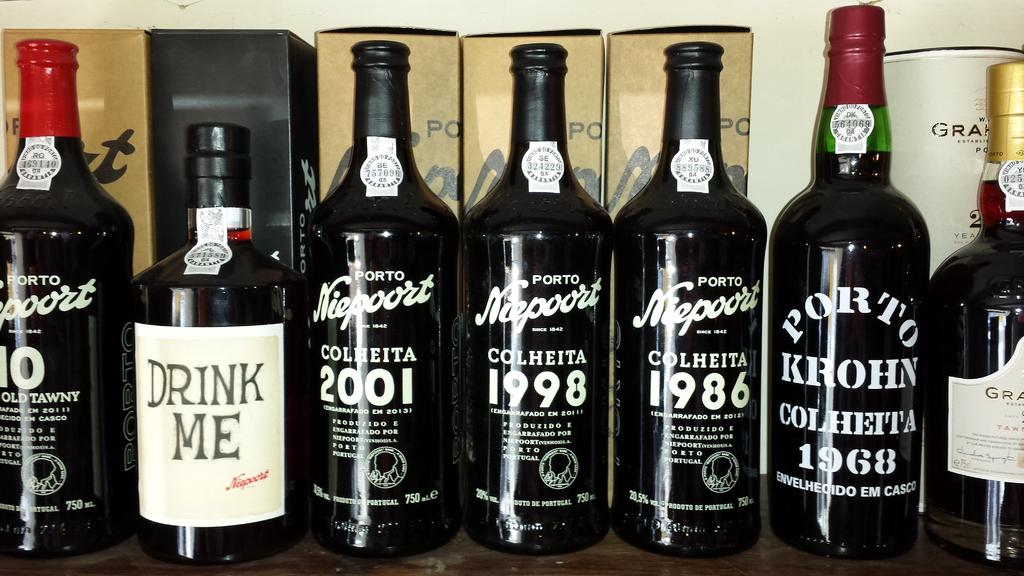What does the second bottle from the left direct someone to do?
Give a very brief answer. Drink me. What brand is the one in the middle?
Ensure brevity in your answer.  Niepoort. 